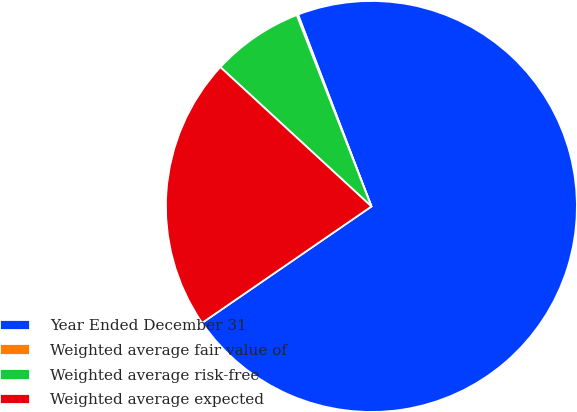Convert chart to OTSL. <chart><loc_0><loc_0><loc_500><loc_500><pie_chart><fcel>Year Ended December 31<fcel>Weighted average fair value of<fcel>Weighted average risk-free<fcel>Weighted average expected<nl><fcel>71.22%<fcel>0.11%<fcel>7.22%<fcel>21.44%<nl></chart> 